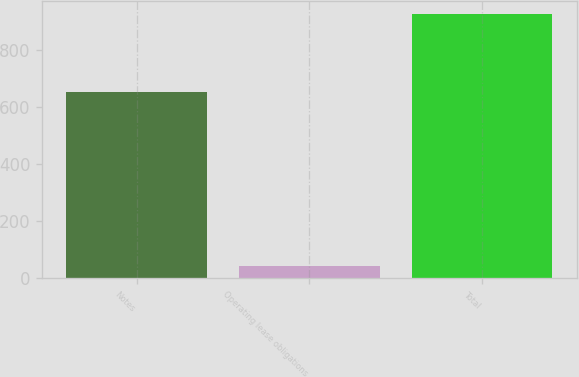Convert chart to OTSL. <chart><loc_0><loc_0><loc_500><loc_500><bar_chart><fcel>Notes<fcel>Operating lease obligations<fcel>Total<nl><fcel>652.5<fcel>42.6<fcel>926.3<nl></chart> 